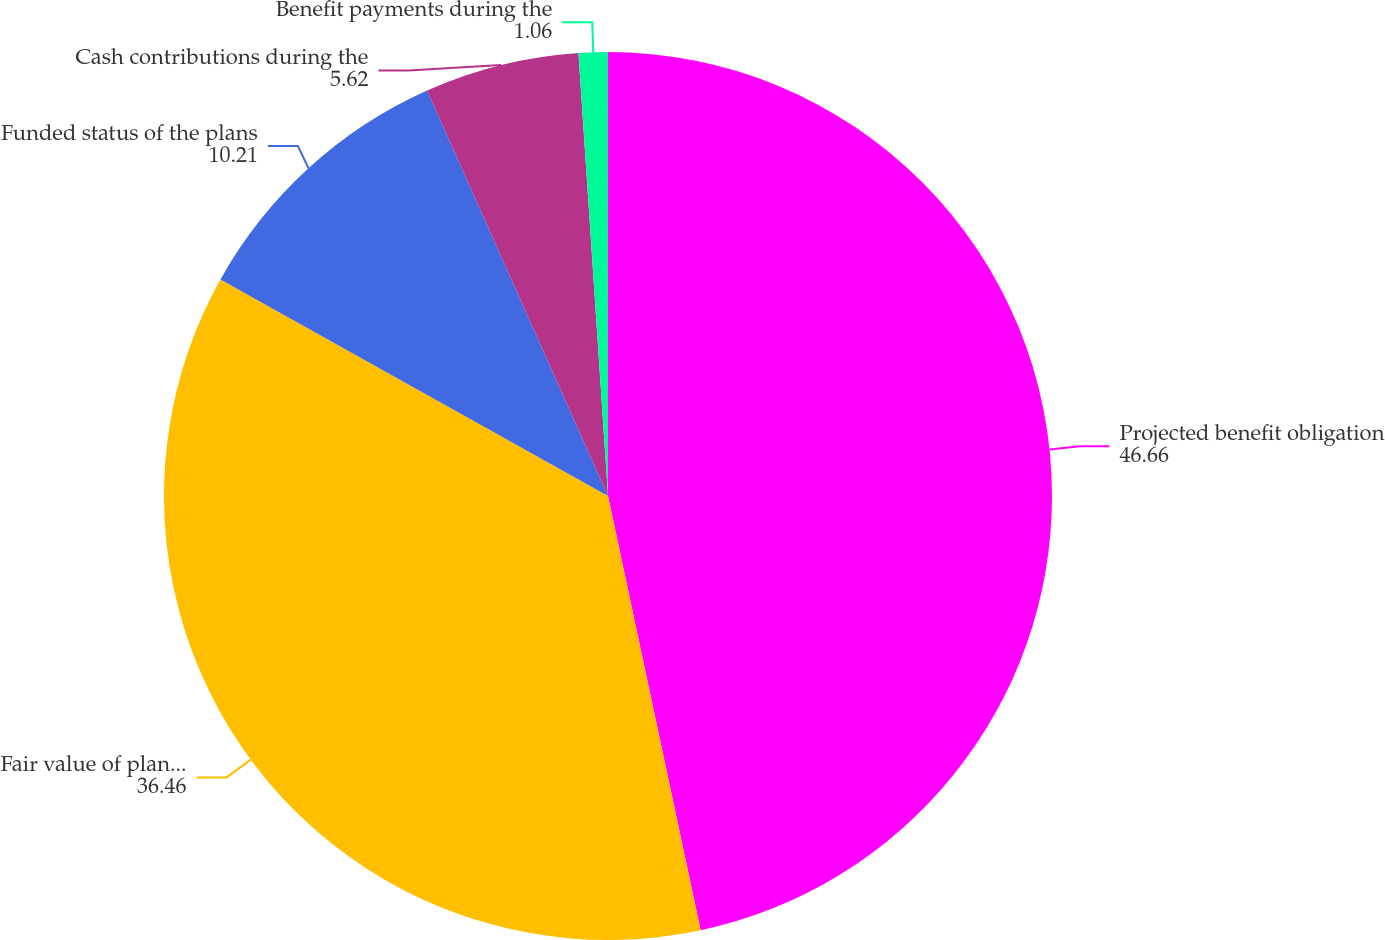Convert chart. <chart><loc_0><loc_0><loc_500><loc_500><pie_chart><fcel>Projected benefit obligation<fcel>Fair value of plan assets<fcel>Funded status of the plans<fcel>Cash contributions during the<fcel>Benefit payments during the<nl><fcel>46.66%<fcel>36.46%<fcel>10.21%<fcel>5.62%<fcel>1.06%<nl></chart> 